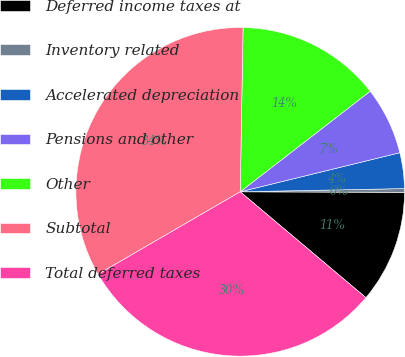Convert chart. <chart><loc_0><loc_0><loc_500><loc_500><pie_chart><fcel>Deferred income taxes at<fcel>Inventory related<fcel>Accelerated depreciation<fcel>Pensions and other<fcel>Other<fcel>Subtotal<fcel>Total deferred taxes<nl><fcel>11.09%<fcel>0.36%<fcel>3.51%<fcel>6.66%<fcel>14.24%<fcel>33.64%<fcel>30.49%<nl></chart> 